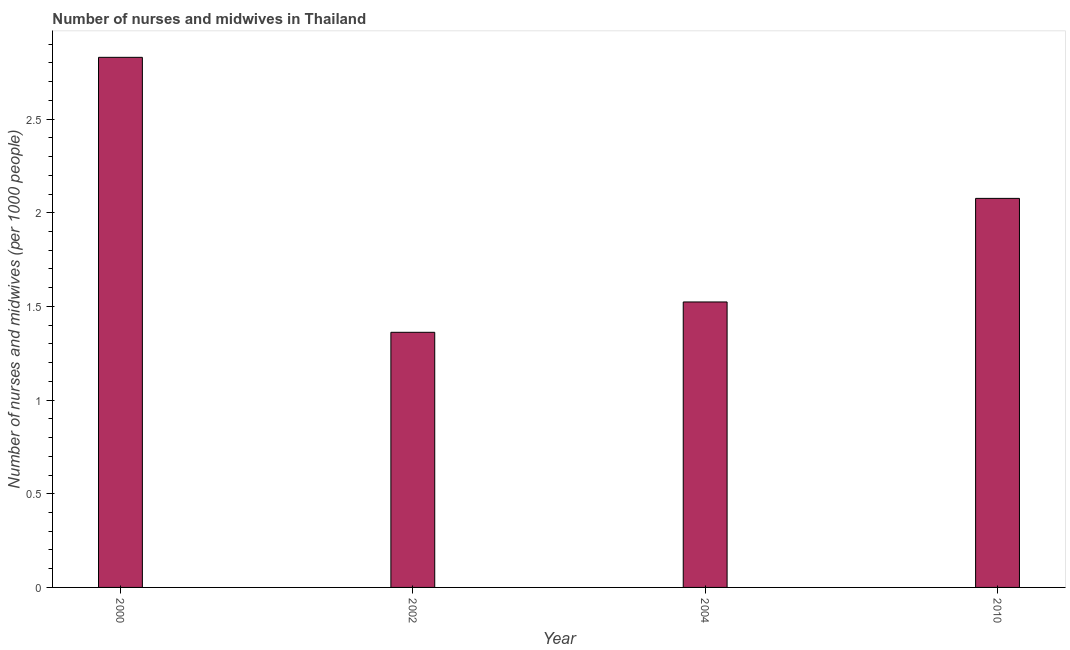What is the title of the graph?
Ensure brevity in your answer.  Number of nurses and midwives in Thailand. What is the label or title of the Y-axis?
Provide a succinct answer. Number of nurses and midwives (per 1000 people). What is the number of nurses and midwives in 2004?
Your answer should be compact. 1.52. Across all years, what is the maximum number of nurses and midwives?
Ensure brevity in your answer.  2.83. Across all years, what is the minimum number of nurses and midwives?
Your answer should be very brief. 1.36. In which year was the number of nurses and midwives maximum?
Provide a succinct answer. 2000. What is the sum of the number of nurses and midwives?
Offer a very short reply. 7.79. What is the difference between the number of nurses and midwives in 2000 and 2002?
Your answer should be very brief. 1.47. What is the average number of nurses and midwives per year?
Your answer should be very brief. 1.95. What is the median number of nurses and midwives?
Ensure brevity in your answer.  1.8. In how many years, is the number of nurses and midwives greater than 2.2 ?
Your answer should be compact. 1. What is the ratio of the number of nurses and midwives in 2000 to that in 2002?
Give a very brief answer. 2.08. Is the difference between the number of nurses and midwives in 2004 and 2010 greater than the difference between any two years?
Provide a short and direct response. No. What is the difference between the highest and the second highest number of nurses and midwives?
Provide a succinct answer. 0.75. What is the difference between the highest and the lowest number of nurses and midwives?
Ensure brevity in your answer.  1.47. How many bars are there?
Keep it short and to the point. 4. Are all the bars in the graph horizontal?
Make the answer very short. No. What is the difference between two consecutive major ticks on the Y-axis?
Offer a terse response. 0.5. Are the values on the major ticks of Y-axis written in scientific E-notation?
Give a very brief answer. No. What is the Number of nurses and midwives (per 1000 people) in 2000?
Ensure brevity in your answer.  2.83. What is the Number of nurses and midwives (per 1000 people) in 2002?
Provide a short and direct response. 1.36. What is the Number of nurses and midwives (per 1000 people) of 2004?
Ensure brevity in your answer.  1.52. What is the Number of nurses and midwives (per 1000 people) of 2010?
Provide a short and direct response. 2.08. What is the difference between the Number of nurses and midwives (per 1000 people) in 2000 and 2002?
Ensure brevity in your answer.  1.47. What is the difference between the Number of nurses and midwives (per 1000 people) in 2000 and 2004?
Ensure brevity in your answer.  1.31. What is the difference between the Number of nurses and midwives (per 1000 people) in 2000 and 2010?
Offer a very short reply. 0.75. What is the difference between the Number of nurses and midwives (per 1000 people) in 2002 and 2004?
Provide a short and direct response. -0.16. What is the difference between the Number of nurses and midwives (per 1000 people) in 2002 and 2010?
Offer a terse response. -0.71. What is the difference between the Number of nurses and midwives (per 1000 people) in 2004 and 2010?
Provide a succinct answer. -0.55. What is the ratio of the Number of nurses and midwives (per 1000 people) in 2000 to that in 2002?
Give a very brief answer. 2.08. What is the ratio of the Number of nurses and midwives (per 1000 people) in 2000 to that in 2004?
Make the answer very short. 1.86. What is the ratio of the Number of nurses and midwives (per 1000 people) in 2000 to that in 2010?
Provide a succinct answer. 1.36. What is the ratio of the Number of nurses and midwives (per 1000 people) in 2002 to that in 2004?
Keep it short and to the point. 0.89. What is the ratio of the Number of nurses and midwives (per 1000 people) in 2002 to that in 2010?
Give a very brief answer. 0.66. What is the ratio of the Number of nurses and midwives (per 1000 people) in 2004 to that in 2010?
Provide a succinct answer. 0.73. 